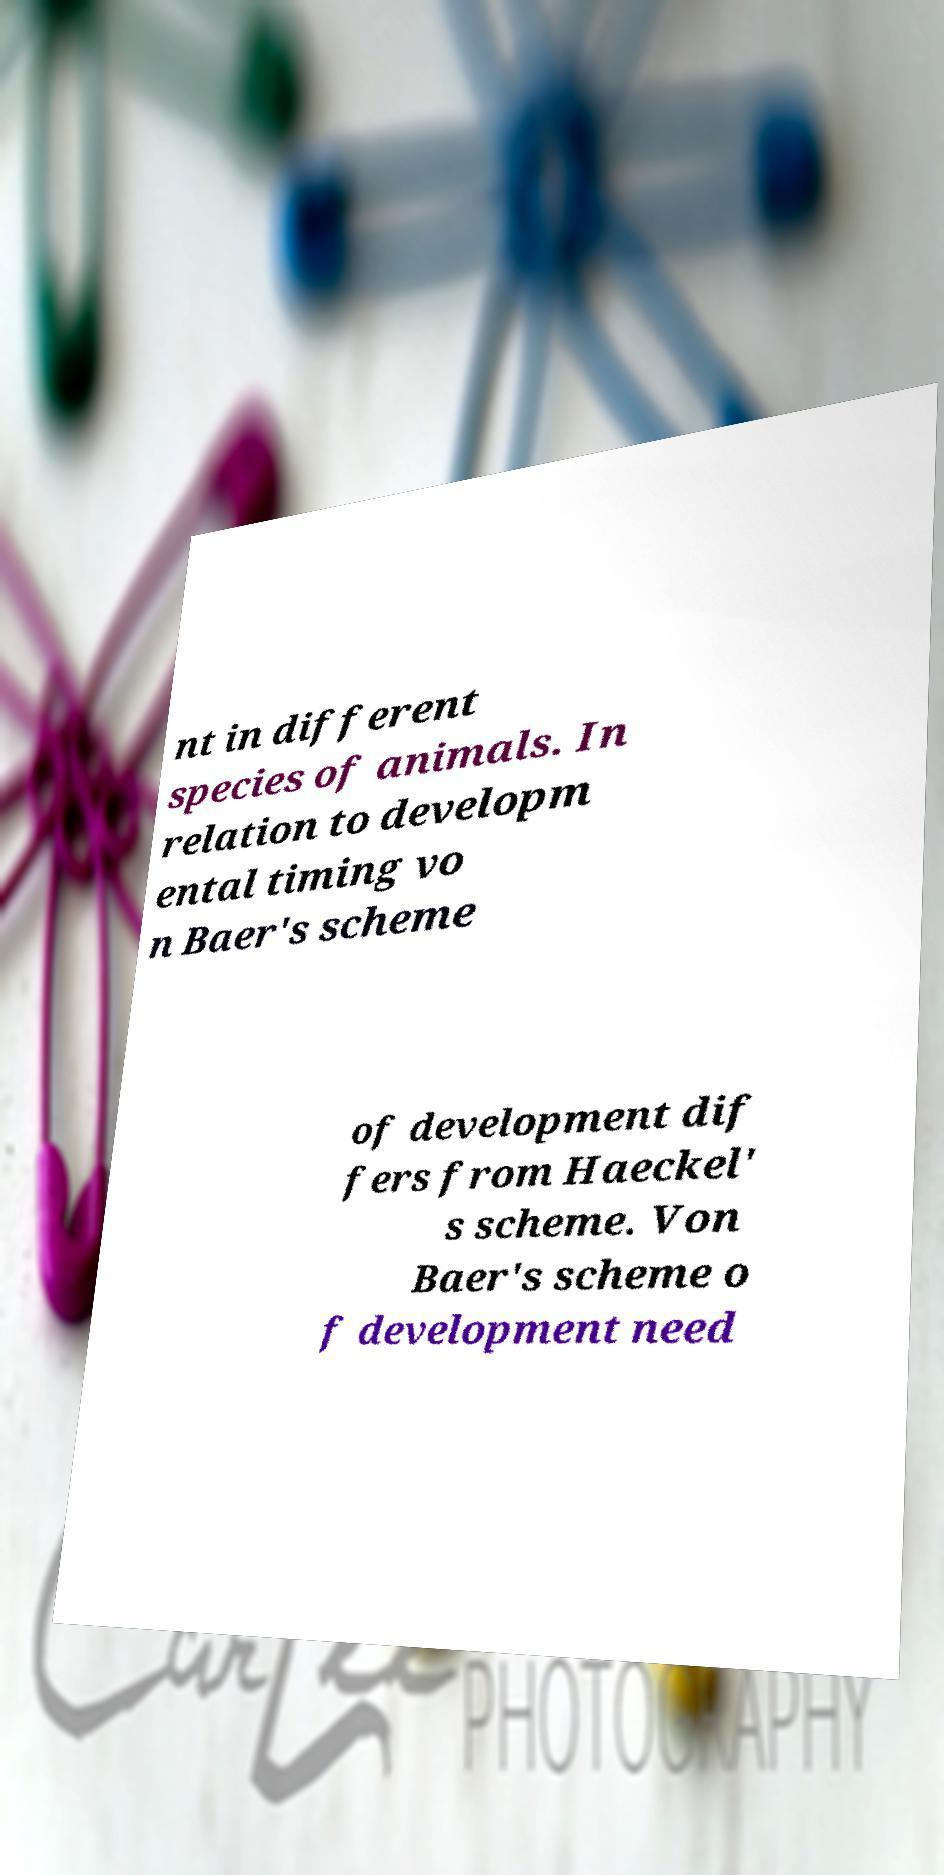I need the written content from this picture converted into text. Can you do that? nt in different species of animals. In relation to developm ental timing vo n Baer's scheme of development dif fers from Haeckel' s scheme. Von Baer's scheme o f development need 